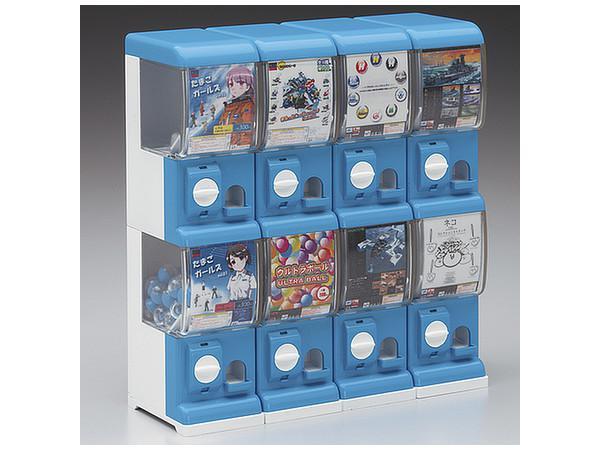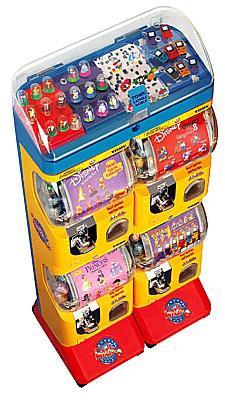The first image is the image on the left, the second image is the image on the right. Examine the images to the left and right. Is the description "There are exactly 3 toy vending machines." accurate? Answer yes or no. No. 